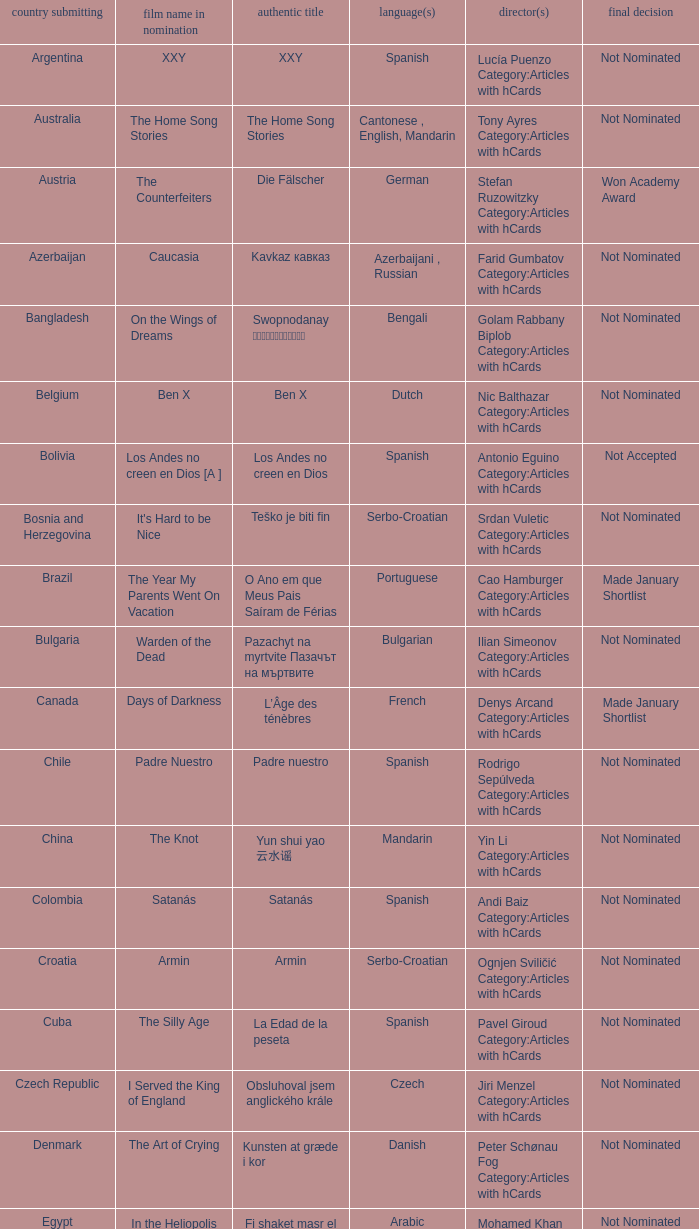What country submitted miehen työ? Finland. 